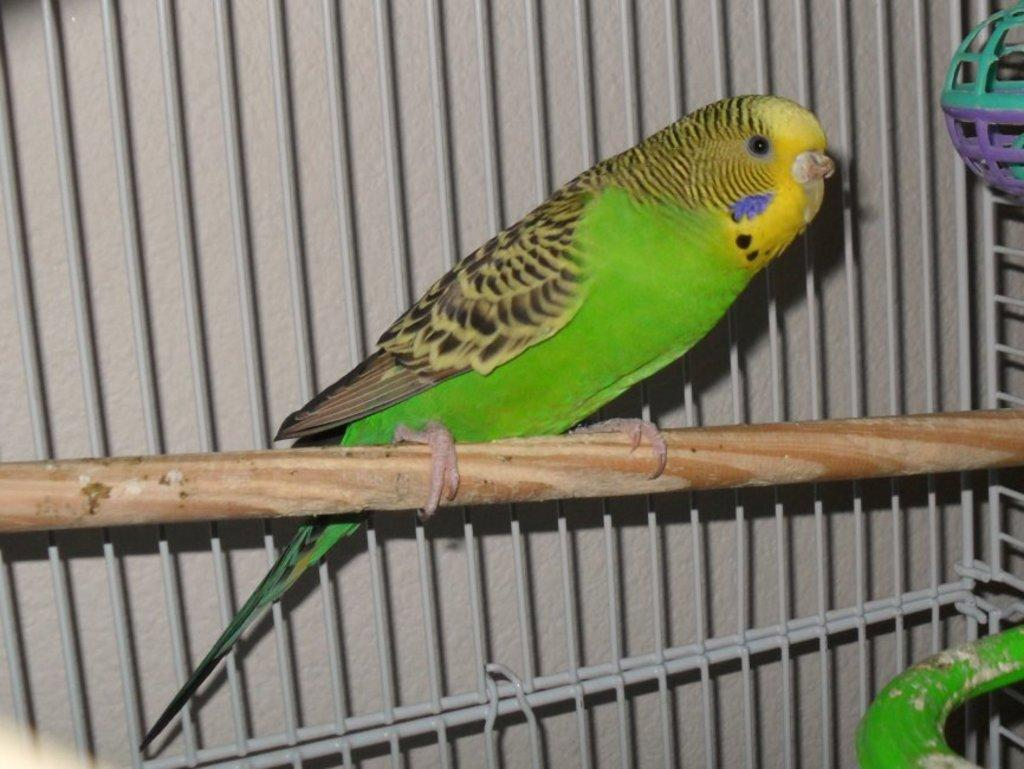What type of animal is in the image? There is a parrot in the image. Where is the parrot located in the image? The parrot is inside a cage. What type of grain is being consumed by the parrot in the image? There is no grain visible in the image, and the parrot is inside a cage, so it cannot be determined if the parrot is consuming any grain. Is the parrot's body on fire in the image? No, the parrot's body is not on fire in the image. 